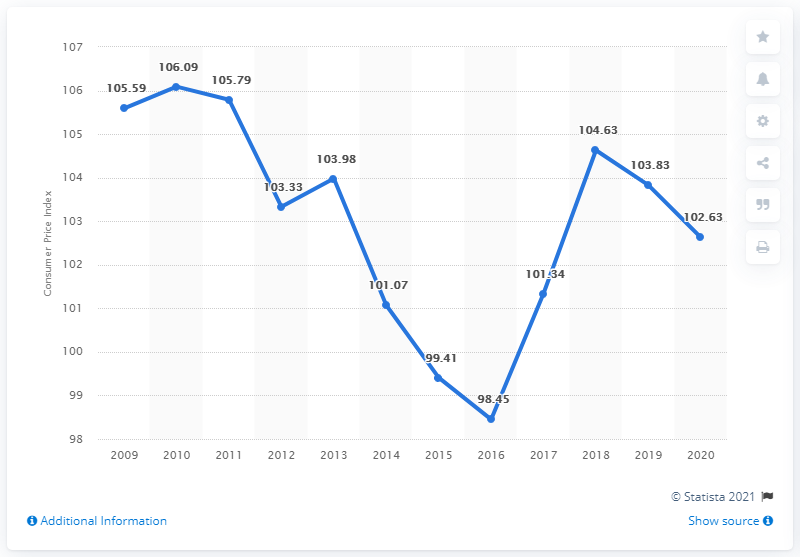List a handful of essential elements in this visual. In 2020, the Consumer Price Index (CPI) in Romania was 102.63. The Consumer Price Index (CPI) in Romania in 2010 was 106.09, which was the highest point in the decade. 